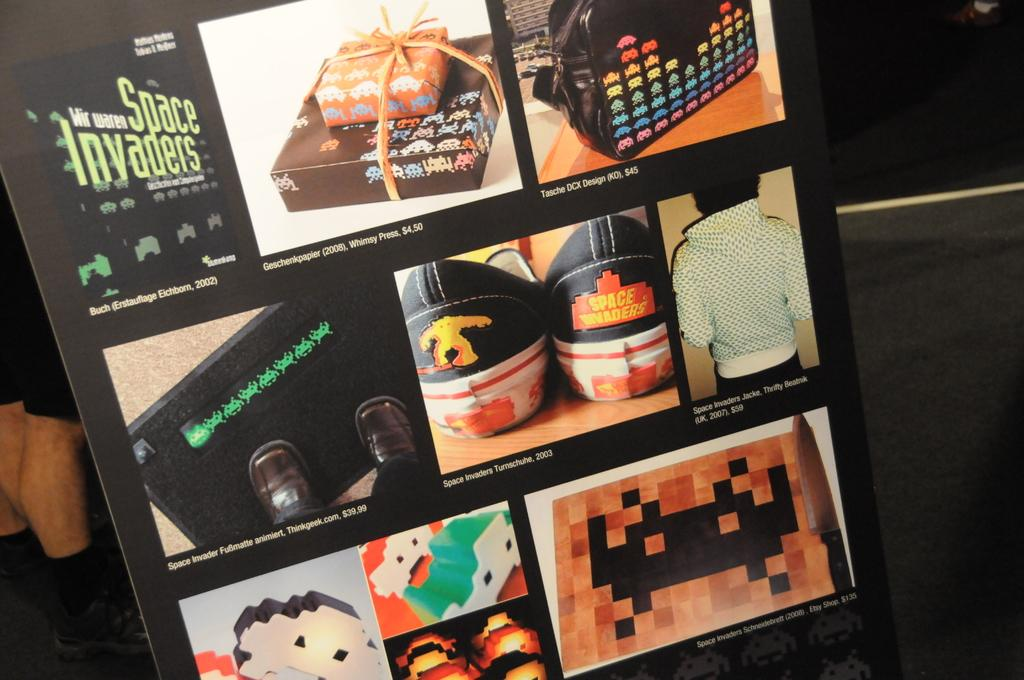<image>
Write a terse but informative summary of the picture. an ad for space invaders market retail sneakers 